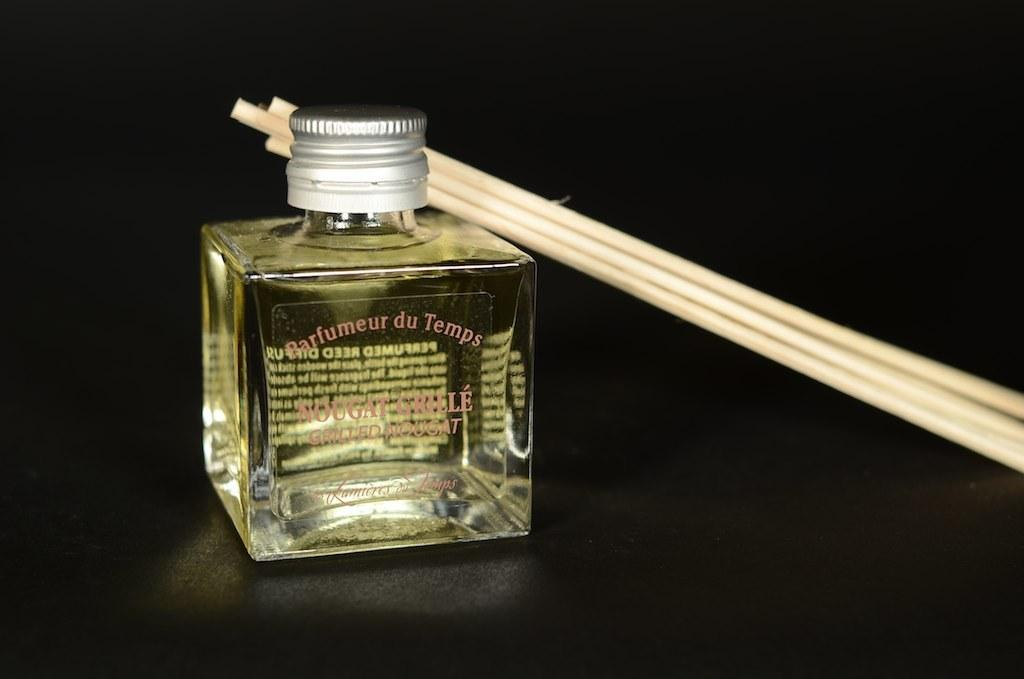<image>
Describe the image concisely. Couple of chopsticks on a cologne bottle that says Nougat Grille. 